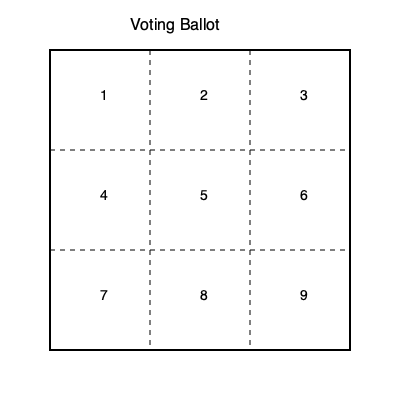Given the voting ballot above, if it were to be folded into a cube, which number would be opposite to the number 5? To solve this problem, we need to mentally fold the ballot paper into a cube and visualize the positions of the numbers. Let's follow these steps:

1. The ballot is divided into a 3x3 grid, which corresponds to the 6 faces of a cube when folded.

2. The central square (number 5) will remain in the center of the cube.

3. When folding into a cube, opposite faces will be:
   - Top and bottom
   - Front and back
   - Left and right

4. In this configuration:
   - 1, 3, 7, and 9 will form the top, bottom, left, and right faces.
   - 2 and 8 will form the front and back faces.

5. The number 5 is in the center, so it won't be on any face of the cube.

6. The number opposite to 5 would be on the face directly opposite to the face containing 5 if it were on a face.

7. Since 5 is in the center, we need to identify which number would be on the opposite side of the cube if we were to extend the center outward.

8. Looking at the ballot, we can see that 5 is surrounded by 2, 4, 6, and 8.

9. The number directly opposite to 5 in this arrangement would be 9, as it's diagonally opposite in the 3x3 grid.

Therefore, if the ballot were folded into a cube, the number opposite to 5 would be 9.
Answer: 9 